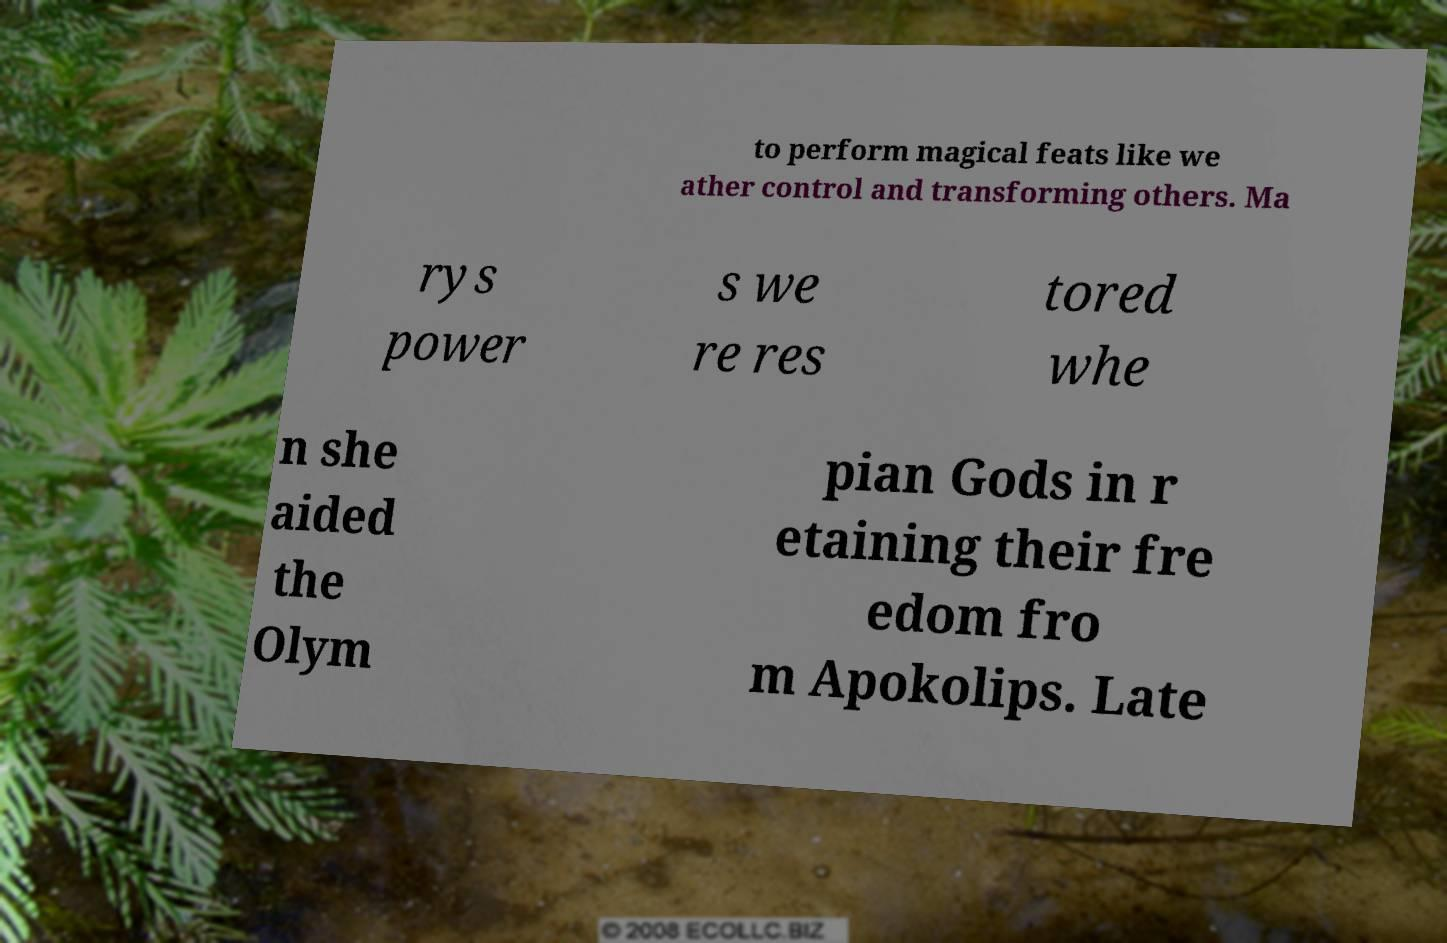Can you read and provide the text displayed in the image?This photo seems to have some interesting text. Can you extract and type it out for me? to perform magical feats like we ather control and transforming others. Ma rys power s we re res tored whe n she aided the Olym pian Gods in r etaining their fre edom fro m Apokolips. Late 